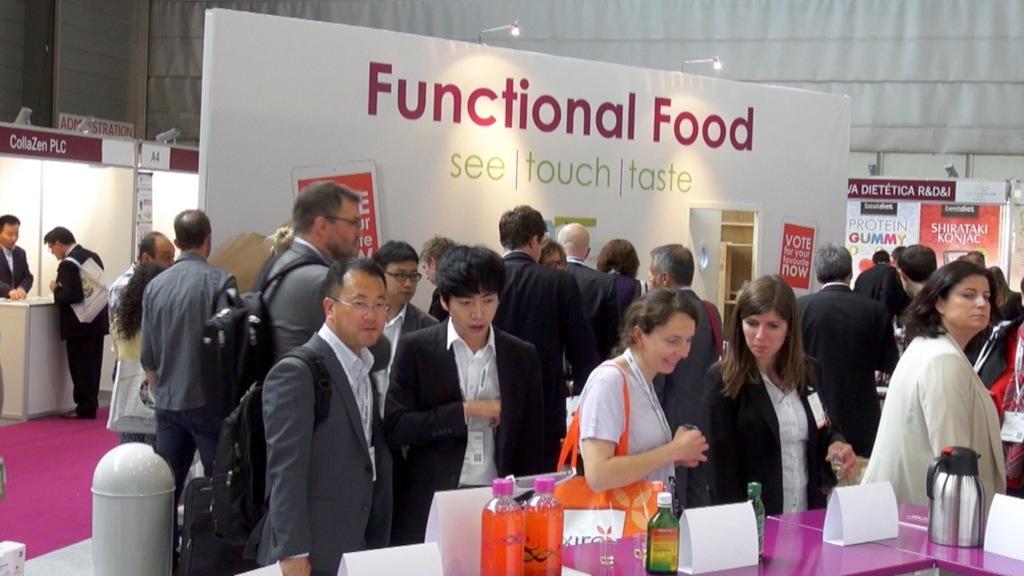In one or two sentences, can you explain what this image depicts? In this picture I can see few people are standing and I can see boards with some text and few bottles, kettle and few name boards on the table and I can see lights. 